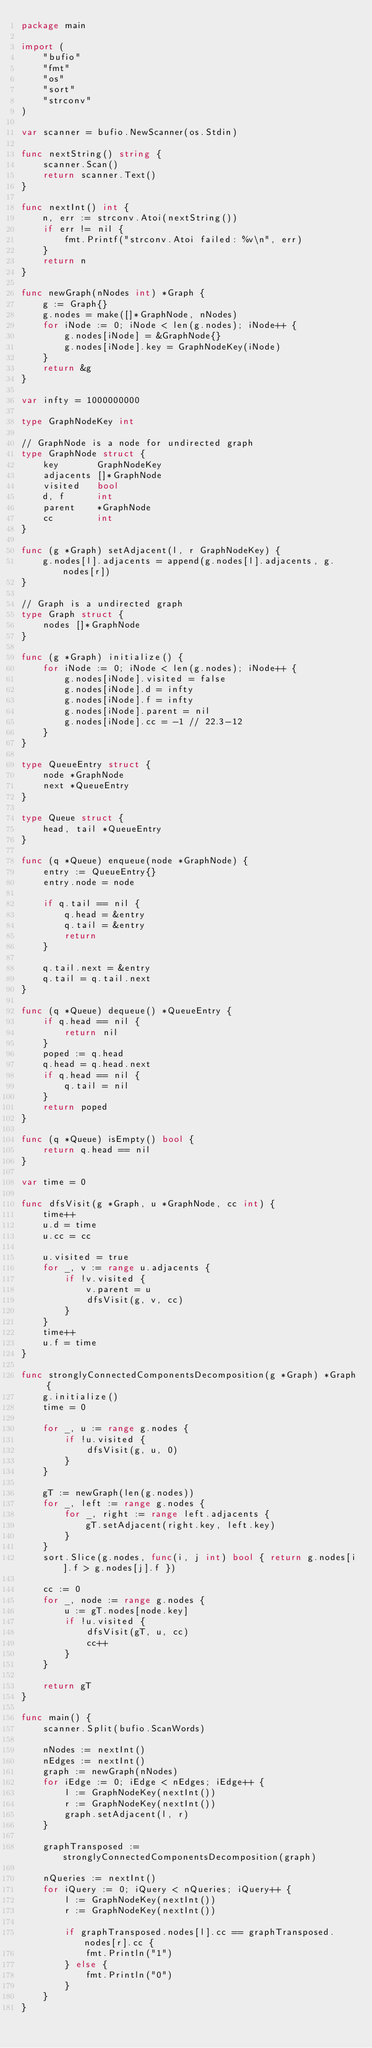Convert code to text. <code><loc_0><loc_0><loc_500><loc_500><_Go_>package main

import (
	"bufio"
	"fmt"
	"os"
	"sort"
	"strconv"
)

var scanner = bufio.NewScanner(os.Stdin)

func nextString() string {
	scanner.Scan()
	return scanner.Text()
}

func nextInt() int {
	n, err := strconv.Atoi(nextString())
	if err != nil {
		fmt.Printf("strconv.Atoi failed: %v\n", err)
	}
	return n
}

func newGraph(nNodes int) *Graph {
	g := Graph{}
	g.nodes = make([]*GraphNode, nNodes)
	for iNode := 0; iNode < len(g.nodes); iNode++ {
		g.nodes[iNode] = &GraphNode{}
		g.nodes[iNode].key = GraphNodeKey(iNode)
	}
	return &g
}

var infty = 1000000000

type GraphNodeKey int

// GraphNode is a node for undirected graph
type GraphNode struct {
	key       GraphNodeKey
	adjacents []*GraphNode
	visited   bool
	d, f      int
	parent    *GraphNode
	cc        int
}

func (g *Graph) setAdjacent(l, r GraphNodeKey) {
	g.nodes[l].adjacents = append(g.nodes[l].adjacents, g.nodes[r])
}

// Graph is a undirected graph
type Graph struct {
	nodes []*GraphNode
}

func (g *Graph) initialize() {
	for iNode := 0; iNode < len(g.nodes); iNode++ {
		g.nodes[iNode].visited = false
		g.nodes[iNode].d = infty
		g.nodes[iNode].f = infty
		g.nodes[iNode].parent = nil
		g.nodes[iNode].cc = -1 // 22.3-12
	}
}

type QueueEntry struct {
	node *GraphNode
	next *QueueEntry
}

type Queue struct {
	head, tail *QueueEntry
}

func (q *Queue) enqueue(node *GraphNode) {
	entry := QueueEntry{}
	entry.node = node

	if q.tail == nil {
		q.head = &entry
		q.tail = &entry
		return
	}

	q.tail.next = &entry
	q.tail = q.tail.next
}

func (q *Queue) dequeue() *QueueEntry {
	if q.head == nil {
		return nil
	}
	poped := q.head
	q.head = q.head.next
	if q.head == nil {
		q.tail = nil
	}
	return poped
}

func (q *Queue) isEmpty() bool {
	return q.head == nil
}

var time = 0

func dfsVisit(g *Graph, u *GraphNode, cc int) {
	time++
	u.d = time
	u.cc = cc

	u.visited = true
	for _, v := range u.adjacents {
		if !v.visited {
			v.parent = u
			dfsVisit(g, v, cc)
		}
	}
	time++
	u.f = time
}

func stronglyConnectedComponentsDecomposition(g *Graph) *Graph {
	g.initialize()
	time = 0

	for _, u := range g.nodes {
		if !u.visited {
			dfsVisit(g, u, 0)
		}
	}

	gT := newGraph(len(g.nodes))
	for _, left := range g.nodes {
		for _, right := range left.adjacents {
			gT.setAdjacent(right.key, left.key)
		}
	}
	sort.Slice(g.nodes, func(i, j int) bool { return g.nodes[i].f > g.nodes[j].f })

	cc := 0
	for _, node := range g.nodes {
		u := gT.nodes[node.key]
		if !u.visited {
			dfsVisit(gT, u, cc)
			cc++
		}
	}

	return gT
}

func main() {
	scanner.Split(bufio.ScanWords)

	nNodes := nextInt()
	nEdges := nextInt()
	graph := newGraph(nNodes)
	for iEdge := 0; iEdge < nEdges; iEdge++ {
		l := GraphNodeKey(nextInt())
		r := GraphNodeKey(nextInt())
		graph.setAdjacent(l, r)
	}

	graphTransposed := stronglyConnectedComponentsDecomposition(graph)

	nQueries := nextInt()
	for iQuery := 0; iQuery < nQueries; iQuery++ {
		l := GraphNodeKey(nextInt())
		r := GraphNodeKey(nextInt())

		if graphTransposed.nodes[l].cc == graphTransposed.nodes[r].cc {
			fmt.Println("1")
		} else {
			fmt.Println("0")
		}
	}
}

</code> 